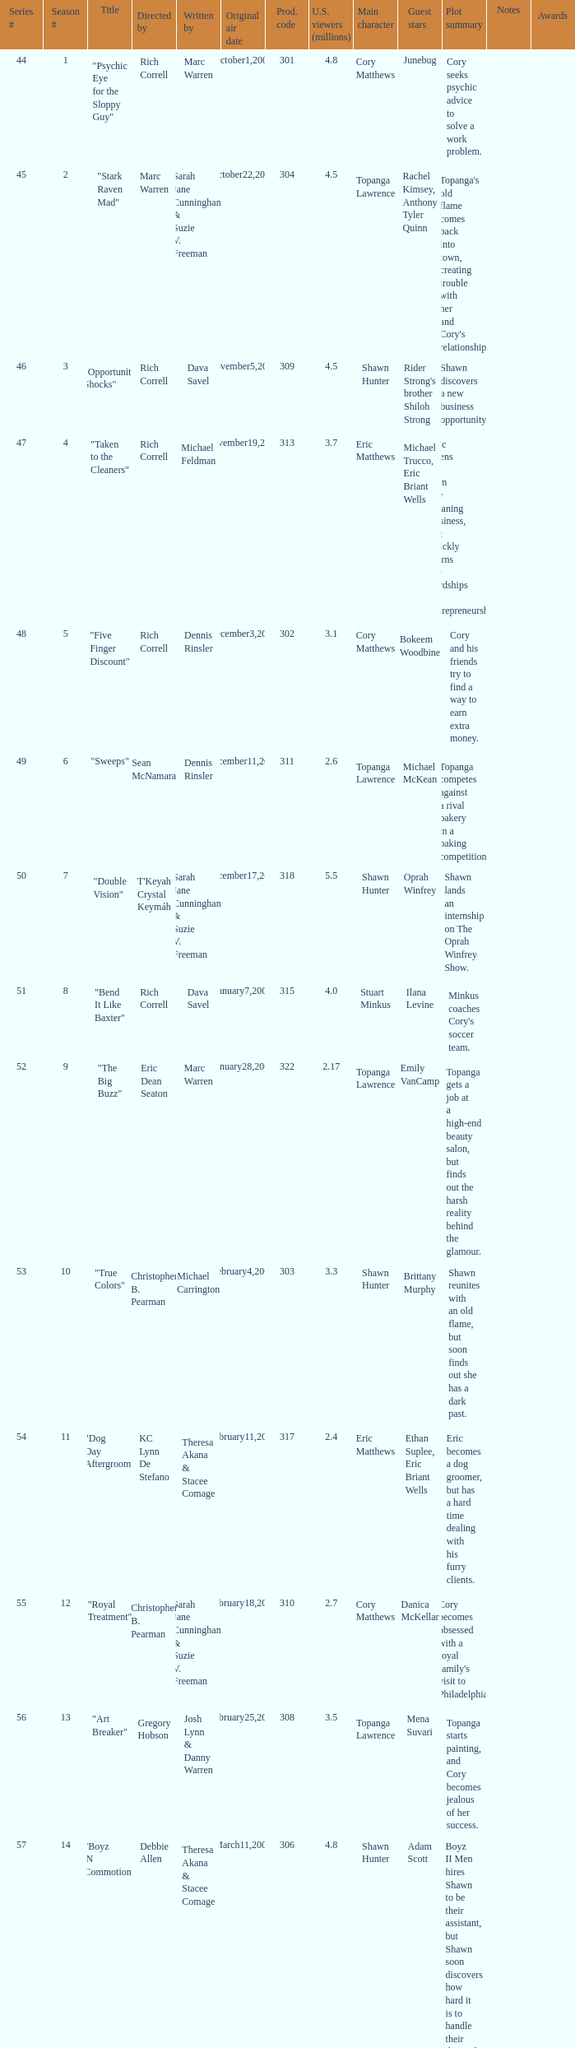What was the production code of the episode directed by Rondell Sheridan?  332.0. 